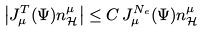Convert formula to latex. <formula><loc_0><loc_0><loc_500><loc_500>\left | J ^ { T } _ { \mu } ( \Psi ) n ^ { \mu } _ { \mathcal { H } } \right | \leq C \, J ^ { N _ { e } } _ { \mu } ( \Psi ) n ^ { \mu } _ { \mathcal { H } }</formula> 